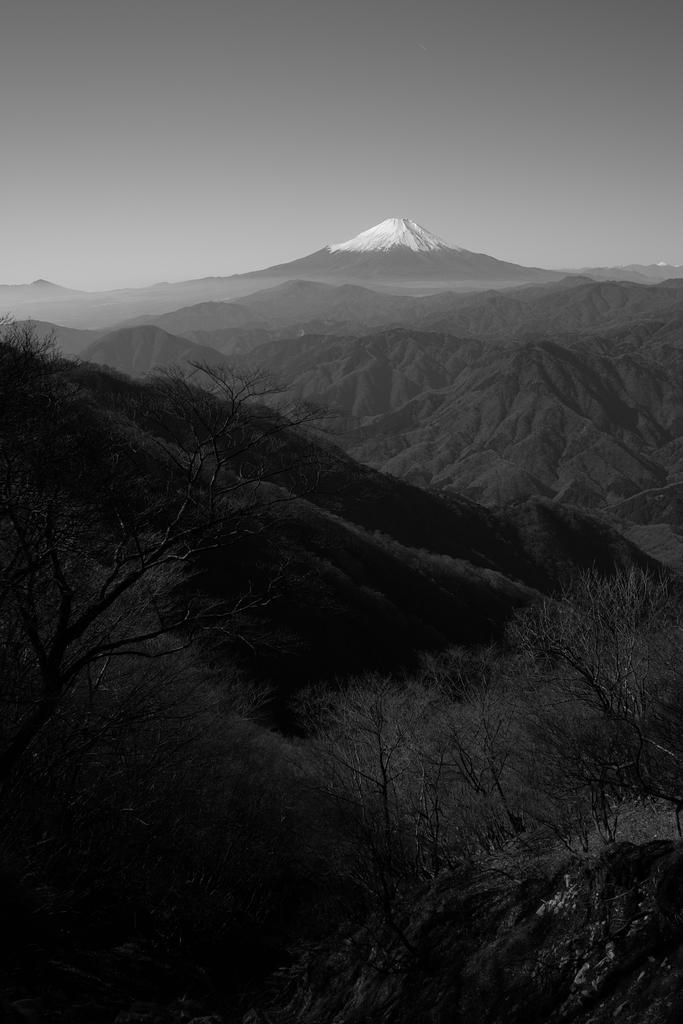Describe this image in one or two sentences. This is a black and white image. In this image we can see trees, hills and sky. 